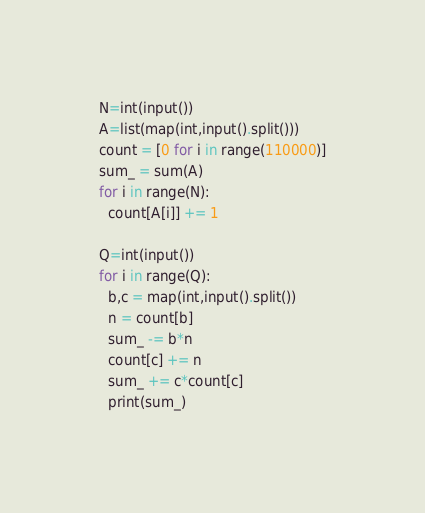Convert code to text. <code><loc_0><loc_0><loc_500><loc_500><_Python_>N=int(input())
A=list(map(int,input().split()))
count = [0 for i in range(110000)]
sum_ = sum(A)
for i in range(N):
  count[A[i]] += 1

Q=int(input())
for i in range(Q):
  b,c = map(int,input().split())
  n = count[b]
  sum_ -= b*n
  count[c] += n
  sum_ += c*count[c]
  print(sum_)</code> 